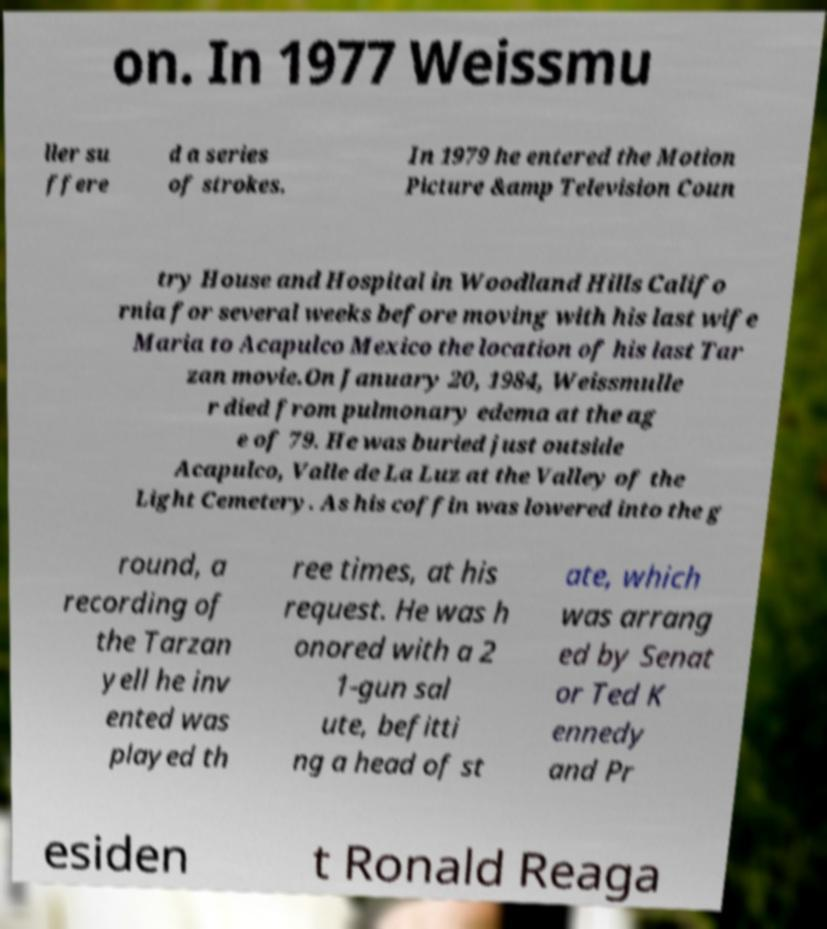For documentation purposes, I need the text within this image transcribed. Could you provide that? on. In 1977 Weissmu ller su ffere d a series of strokes. In 1979 he entered the Motion Picture &amp Television Coun try House and Hospital in Woodland Hills Califo rnia for several weeks before moving with his last wife Maria to Acapulco Mexico the location of his last Tar zan movie.On January 20, 1984, Weissmulle r died from pulmonary edema at the ag e of 79. He was buried just outside Acapulco, Valle de La Luz at the Valley of the Light Cemetery. As his coffin was lowered into the g round, a recording of the Tarzan yell he inv ented was played th ree times, at his request. He was h onored with a 2 1-gun sal ute, befitti ng a head of st ate, which was arrang ed by Senat or Ted K ennedy and Pr esiden t Ronald Reaga 